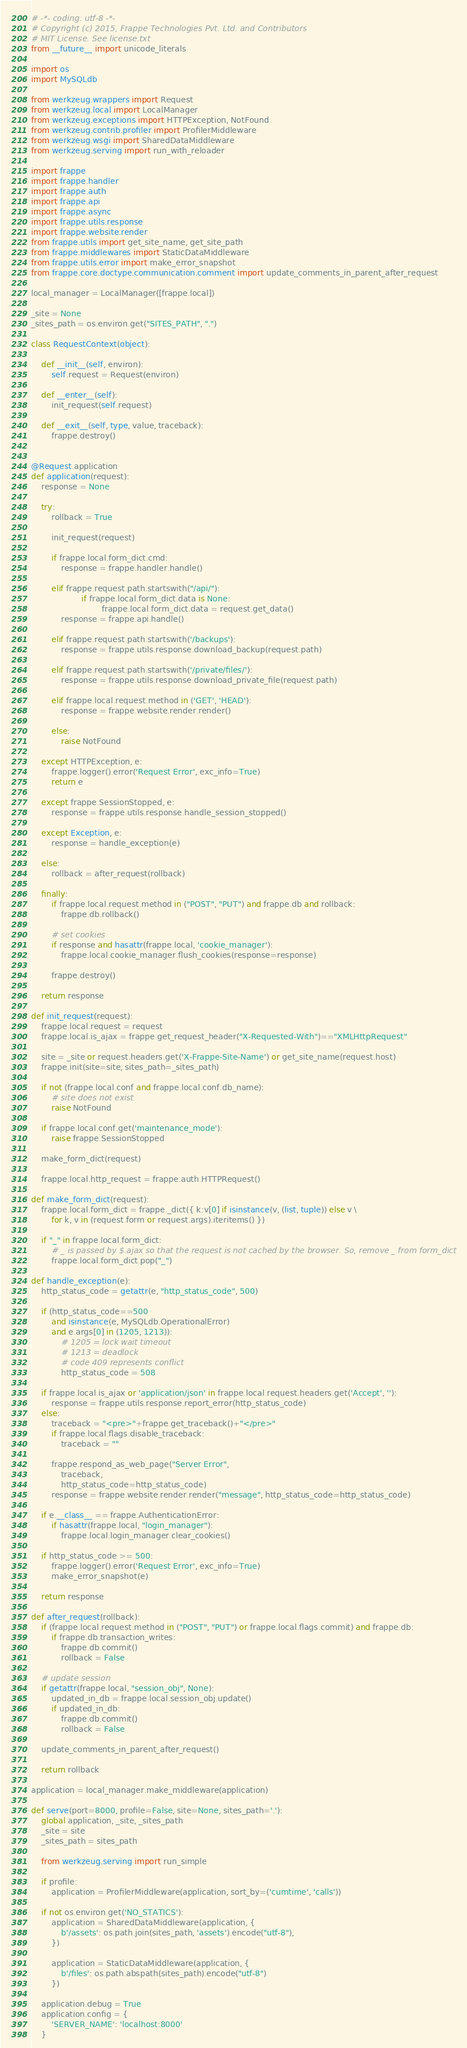Convert code to text. <code><loc_0><loc_0><loc_500><loc_500><_Python_># -*- coding: utf-8 -*-
# Copyright (c) 2015, Frappe Technologies Pvt. Ltd. and Contributors
# MIT License. See license.txt
from __future__ import unicode_literals

import os
import MySQLdb

from werkzeug.wrappers import Request
from werkzeug.local import LocalManager
from werkzeug.exceptions import HTTPException, NotFound
from werkzeug.contrib.profiler import ProfilerMiddleware
from werkzeug.wsgi import SharedDataMiddleware
from werkzeug.serving import run_with_reloader

import frappe
import frappe.handler
import frappe.auth
import frappe.api
import frappe.async
import frappe.utils.response
import frappe.website.render
from frappe.utils import get_site_name, get_site_path
from frappe.middlewares import StaticDataMiddleware
from frappe.utils.error import make_error_snapshot
from frappe.core.doctype.communication.comment import update_comments_in_parent_after_request

local_manager = LocalManager([frappe.local])

_site = None
_sites_path = os.environ.get("SITES_PATH", ".")

class RequestContext(object):

	def __init__(self, environ):
		self.request = Request(environ)

	def __enter__(self):
		init_request(self.request)

	def __exit__(self, type, value, traceback):
		frappe.destroy()


@Request.application
def application(request):
	response = None

	try:
		rollback = True

		init_request(request)

		if frappe.local.form_dict.cmd:
			response = frappe.handler.handle()

		elif frappe.request.path.startswith("/api/"):
                	if frappe.local.form_dict.data is None:
                        	frappe.local.form_dict.data = request.get_data()
			response = frappe.api.handle()

		elif frappe.request.path.startswith('/backups'):
			response = frappe.utils.response.download_backup(request.path)

		elif frappe.request.path.startswith('/private/files/'):
			response = frappe.utils.response.download_private_file(request.path)

		elif frappe.local.request.method in ('GET', 'HEAD'):
			response = frappe.website.render.render()

		else:
			raise NotFound

	except HTTPException, e:
		frappe.logger().error('Request Error', exc_info=True)
		return e

	except frappe.SessionStopped, e:
		response = frappe.utils.response.handle_session_stopped()

	except Exception, e:
		response = handle_exception(e)

	else:
		rollback = after_request(rollback)

	finally:
		if frappe.local.request.method in ("POST", "PUT") and frappe.db and rollback:
			frappe.db.rollback()

		# set cookies
		if response and hasattr(frappe.local, 'cookie_manager'):
			frappe.local.cookie_manager.flush_cookies(response=response)

		frappe.destroy()

	return response

def init_request(request):
	frappe.local.request = request
	frappe.local.is_ajax = frappe.get_request_header("X-Requested-With")=="XMLHttpRequest"

	site = _site or request.headers.get('X-Frappe-Site-Name') or get_site_name(request.host)
	frappe.init(site=site, sites_path=_sites_path)

	if not (frappe.local.conf and frappe.local.conf.db_name):
		# site does not exist
		raise NotFound

	if frappe.local.conf.get('maintenance_mode'):
		raise frappe.SessionStopped

	make_form_dict(request)

	frappe.local.http_request = frappe.auth.HTTPRequest()

def make_form_dict(request):
	frappe.local.form_dict = frappe._dict({ k:v[0] if isinstance(v, (list, tuple)) else v \
		for k, v in (request.form or request.args).iteritems() })

	if "_" in frappe.local.form_dict:
		# _ is passed by $.ajax so that the request is not cached by the browser. So, remove _ from form_dict
		frappe.local.form_dict.pop("_")

def handle_exception(e):
	http_status_code = getattr(e, "http_status_code", 500)

	if (http_status_code==500
		and isinstance(e, MySQLdb.OperationalError)
		and e.args[0] in (1205, 1213)):
			# 1205 = lock wait timeout
			# 1213 = deadlock
			# code 409 represents conflict
			http_status_code = 508

	if frappe.local.is_ajax or 'application/json' in frappe.local.request.headers.get('Accept', ''):
		response = frappe.utils.response.report_error(http_status_code)
	else:
		traceback = "<pre>"+frappe.get_traceback()+"</pre>"
		if frappe.local.flags.disable_traceback:
			traceback = ""

		frappe.respond_as_web_page("Server Error",
			traceback,
			http_status_code=http_status_code)
		response = frappe.website.render.render("message", http_status_code=http_status_code)

	if e.__class__ == frappe.AuthenticationError:
		if hasattr(frappe.local, "login_manager"):
			frappe.local.login_manager.clear_cookies()

	if http_status_code >= 500:
		frappe.logger().error('Request Error', exc_info=True)
		make_error_snapshot(e)

	return response

def after_request(rollback):
	if (frappe.local.request.method in ("POST", "PUT") or frappe.local.flags.commit) and frappe.db:
		if frappe.db.transaction_writes:
			frappe.db.commit()
			rollback = False

	# update session
	if getattr(frappe.local, "session_obj", None):
		updated_in_db = frappe.local.session_obj.update()
		if updated_in_db:
			frappe.db.commit()
			rollback = False

	update_comments_in_parent_after_request()

	return rollback

application = local_manager.make_middleware(application)

def serve(port=8000, profile=False, site=None, sites_path='.'):
	global application, _site, _sites_path
	_site = site
	_sites_path = sites_path

	from werkzeug.serving import run_simple

	if profile:
		application = ProfilerMiddleware(application, sort_by=('cumtime', 'calls'))

	if not os.environ.get('NO_STATICS'):
		application = SharedDataMiddleware(application, {
			b'/assets': os.path.join(sites_path, 'assets').encode("utf-8"),
		})

		application = StaticDataMiddleware(application, {
			b'/files': os.path.abspath(sites_path).encode("utf-8")
		})

	application.debug = True
	application.config = {
		'SERVER_NAME': 'localhost:8000'
	}
</code> 